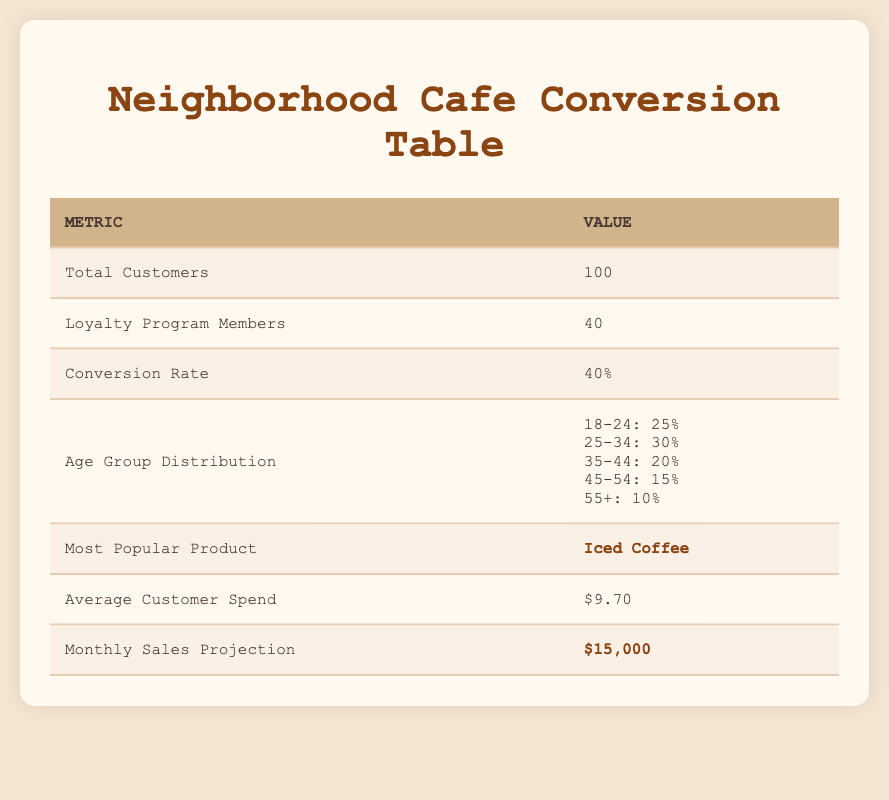What percentage of customers are members of the loyalty program? The table states there are 40 loyalty program members out of a total of 100 customers. To find the percentage, we use the formula: (40 / 100) * 100 = 40%.
Answer: 40% What is the most popular product according to the data? The table clearly highlights that the most popular product is "Iced Coffee."
Answer: Iced Coffee How much does the average customer spend? The table shows that the average customer spend is $9.70.
Answer: $9.70 What is the age group with the highest distribution? Looking at the age group distribution in the table, the age group "25-34" has the highest percentage at 30%.
Answer: 25-34 What is the projected sales for the month? The table lists the monthly sales projection as $15,000.
Answer: $15,000 What is the purchasing frequency of customers aged 55+? According to the demographic data, customers in the age group of 55+ have a purchasing frequency labeled as "Occasionally."
Answer: Occasionally Is there any age group that has no loyalty program members? The demographic data shows that the age group "25-34" and "45-54" do not have any loyalty program members denoting they are not part of the loyalty program. Therefore, yes, there are age groups without loyalty members.
Answer: Yes What is the difference in average spend between the age groups 18-24 and 35-44? The average spend for the 18-24 age group is $7.50 and for the 35-44 age group is $15.00. To find the difference: $15.00 - $7.50 = $7.50.
Answer: $7.50 If 40% of total customers are in the loyalty program, how many customers are not members of the loyalty program? The total number of customers is 100. We know that 40% are loyalty program members, which is 40 customers. Thus, the number of customers not in the loyalty program is 100 - 40 = 60.
Answer: 60 